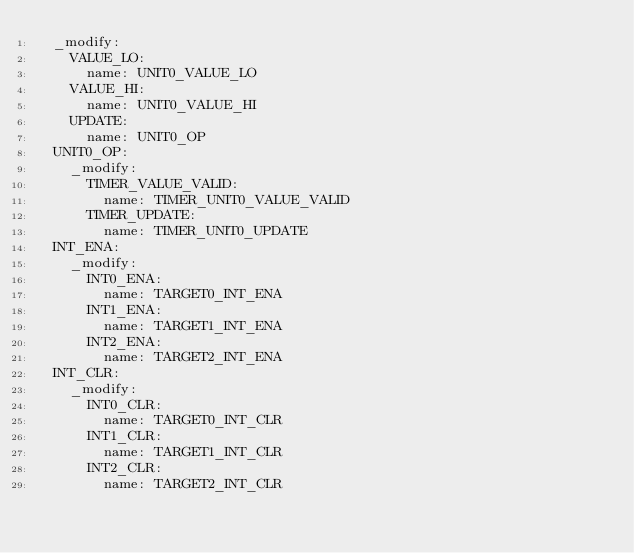<code> <loc_0><loc_0><loc_500><loc_500><_YAML_>  _modify:
    VALUE_LO:
      name: UNIT0_VALUE_LO
    VALUE_HI:
      name: UNIT0_VALUE_HI
    UPDATE:
      name: UNIT0_OP
  UNIT0_OP:
    _modify:
      TIMER_VALUE_VALID:
        name: TIMER_UNIT0_VALUE_VALID
      TIMER_UPDATE:
        name: TIMER_UNIT0_UPDATE
  INT_ENA:
    _modify:
      INT0_ENA:
        name: TARGET0_INT_ENA
      INT1_ENA:
        name: TARGET1_INT_ENA
      INT2_ENA:
        name: TARGET2_INT_ENA
  INT_CLR:
    _modify:
      INT0_CLR:
        name: TARGET0_INT_CLR
      INT1_CLR:
        name: TARGET1_INT_CLR
      INT2_CLR:
        name: TARGET2_INT_CLR
    
            </code> 